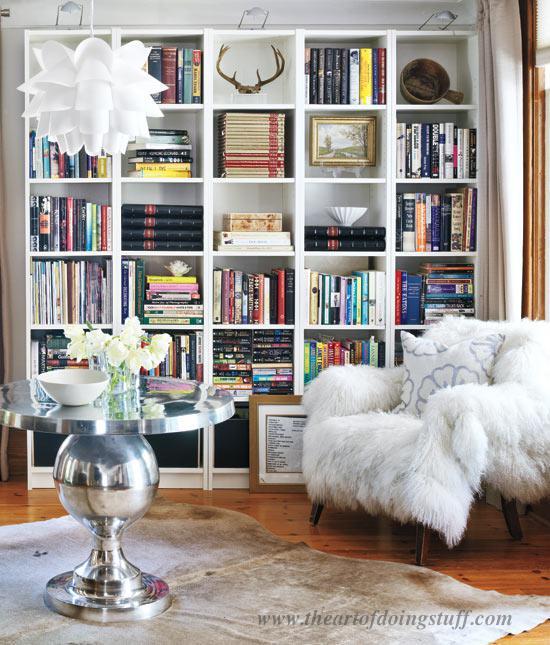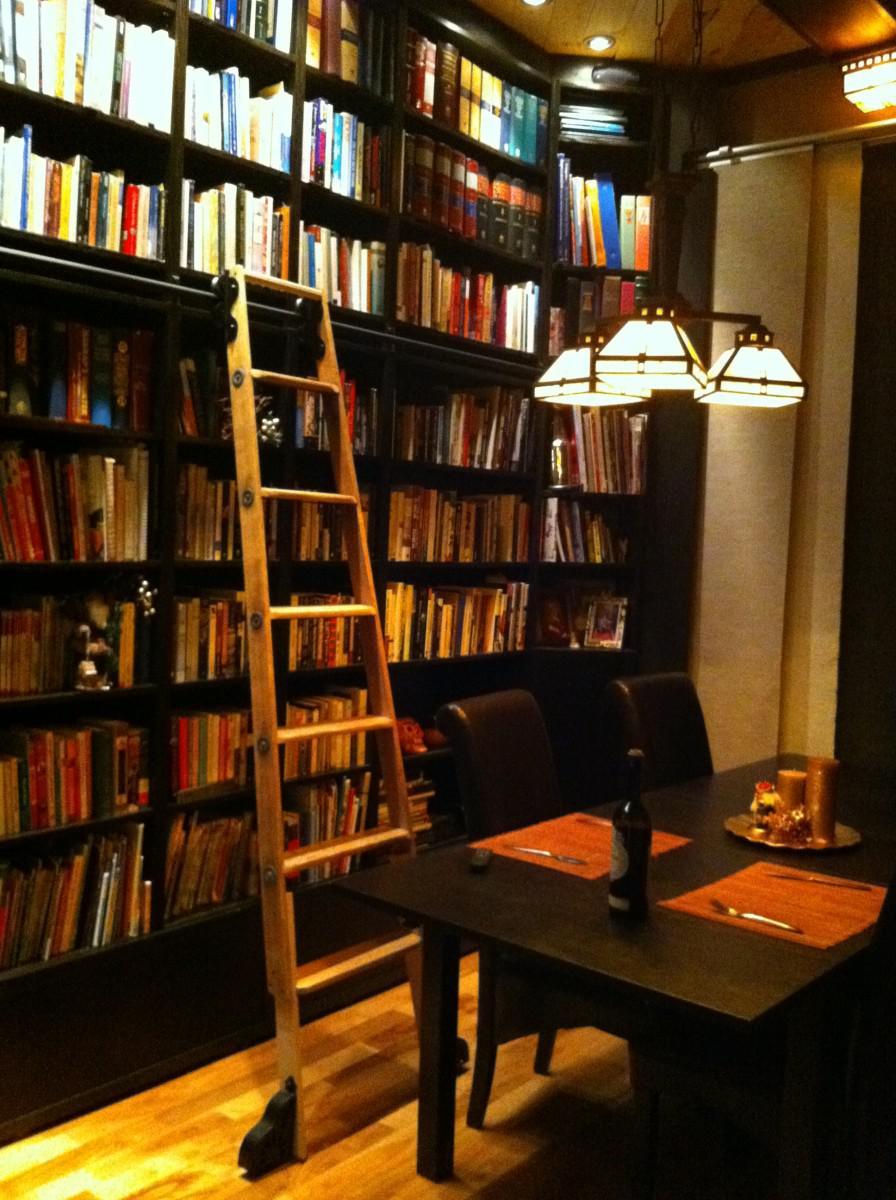The first image is the image on the left, the second image is the image on the right. For the images shown, is this caption "An image contains a large white bookshelf with an acoustic guitar on a stand in front of it." true? Answer yes or no. No. 